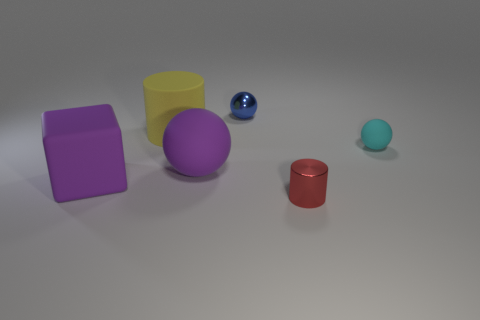Add 2 big purple matte blocks. How many objects exist? 8 Subtract all blocks. How many objects are left? 5 Add 6 yellow objects. How many yellow objects are left? 7 Add 2 small blue shiny objects. How many small blue shiny objects exist? 3 Subtract 0 red blocks. How many objects are left? 6 Subtract all blue spheres. Subtract all red cylinders. How many objects are left? 4 